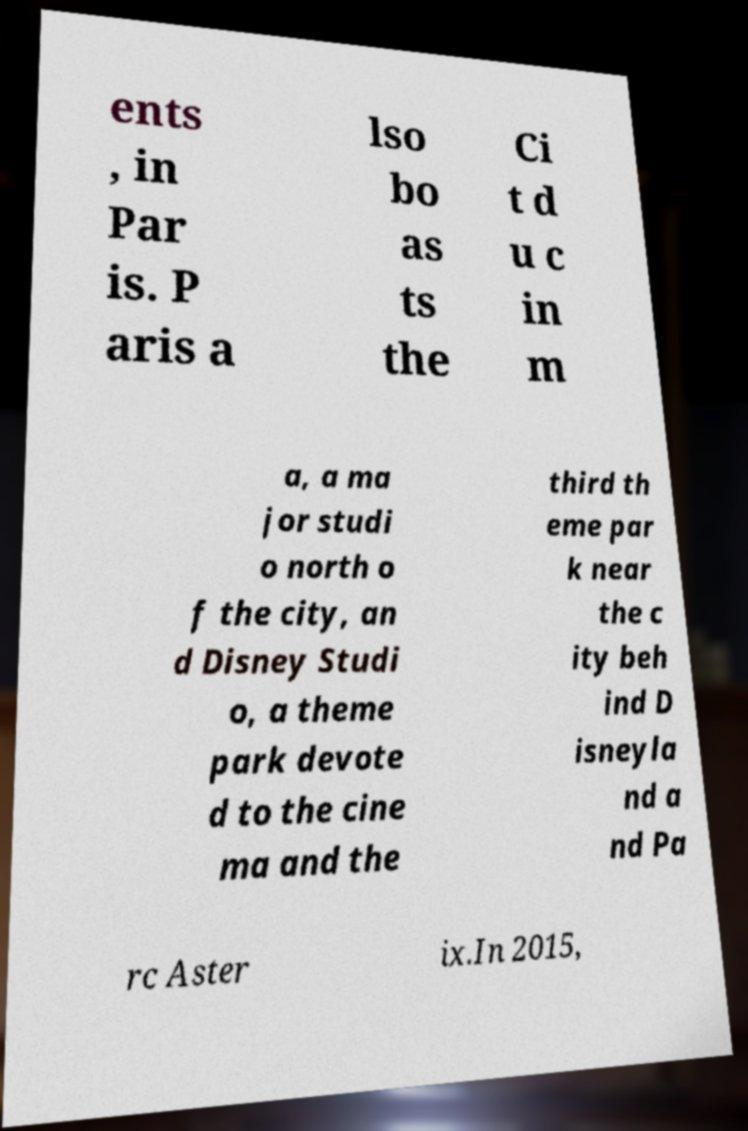I need the written content from this picture converted into text. Can you do that? ents , in Par is. P aris a lso bo as ts the Ci t d u c in m a, a ma jor studi o north o f the city, an d Disney Studi o, a theme park devote d to the cine ma and the third th eme par k near the c ity beh ind D isneyla nd a nd Pa rc Aster ix.In 2015, 